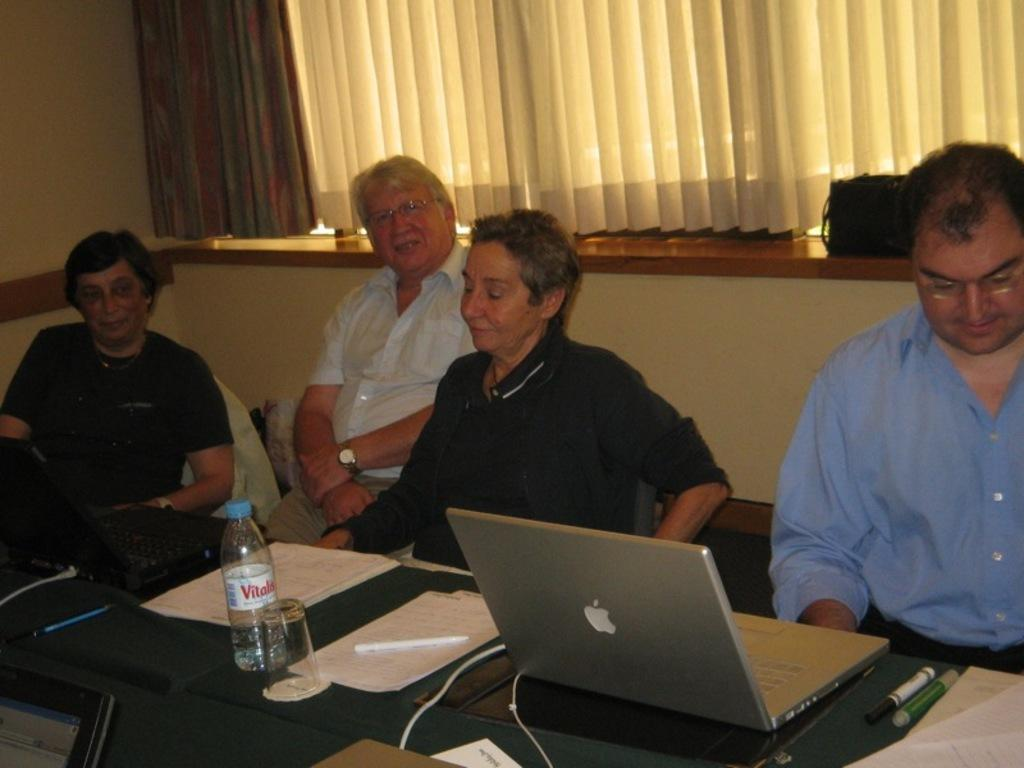How many people are sitting on the chair in the image? There are four people sitting on a chair in the image. What is present on the table in the image? There is a laptop, paper, a pen, a bottle, and a glass on the table in the image. What can be seen in the background of the image? There is a curtain in the background. What decision was made by the people sitting on the chair in the image? There is no indication of a decision being made in the image; it only shows four people sitting on a chair. What way was the produce delivered in the image? There is no produce or delivery mentioned in the image; it only shows a table with various items on it and a curtain in the background. 